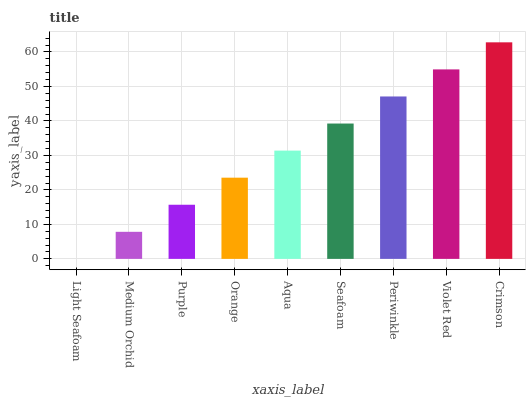Is Light Seafoam the minimum?
Answer yes or no. Yes. Is Crimson the maximum?
Answer yes or no. Yes. Is Medium Orchid the minimum?
Answer yes or no. No. Is Medium Orchid the maximum?
Answer yes or no. No. Is Medium Orchid greater than Light Seafoam?
Answer yes or no. Yes. Is Light Seafoam less than Medium Orchid?
Answer yes or no. Yes. Is Light Seafoam greater than Medium Orchid?
Answer yes or no. No. Is Medium Orchid less than Light Seafoam?
Answer yes or no. No. Is Aqua the high median?
Answer yes or no. Yes. Is Aqua the low median?
Answer yes or no. Yes. Is Crimson the high median?
Answer yes or no. No. Is Crimson the low median?
Answer yes or no. No. 